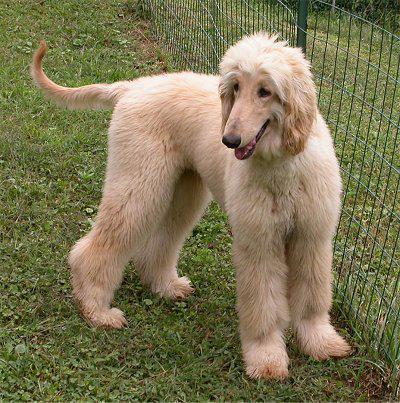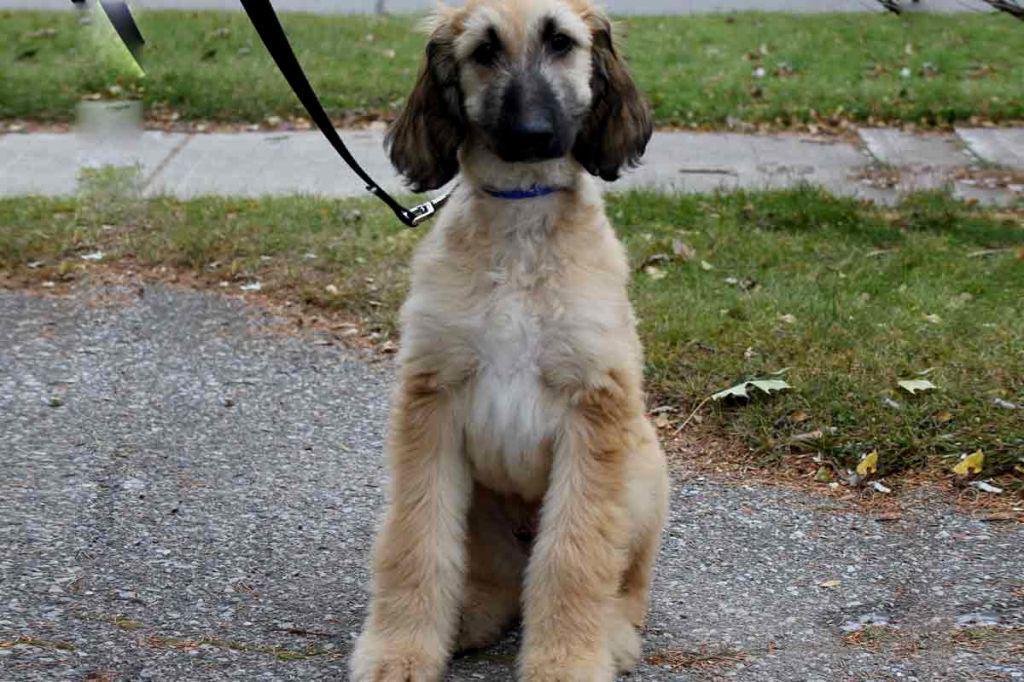The first image is the image on the left, the second image is the image on the right. For the images displayed, is the sentence "One dog is looking left and one dog is looking straight ahead." factually correct? Answer yes or no. Yes. 